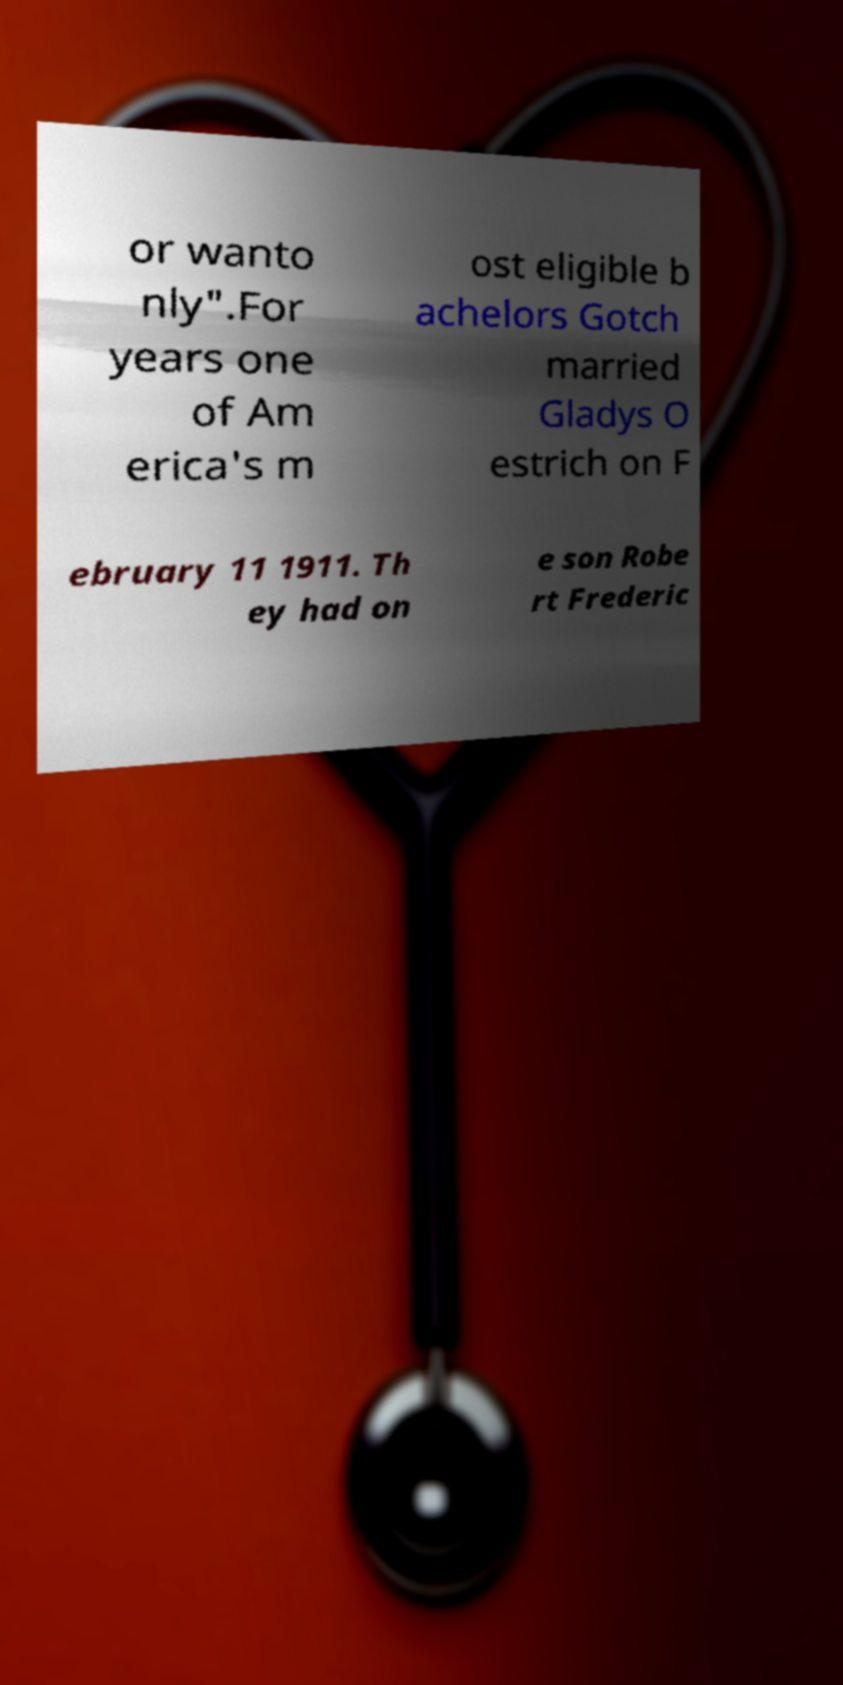I need the written content from this picture converted into text. Can you do that? or wanto nly".For years one of Am erica's m ost eligible b achelors Gotch married Gladys O estrich on F ebruary 11 1911. Th ey had on e son Robe rt Frederic 